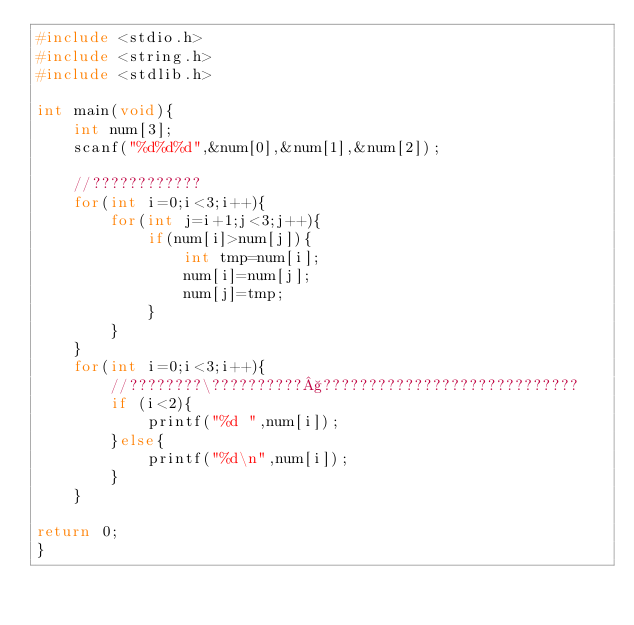<code> <loc_0><loc_0><loc_500><loc_500><_C_>#include <stdio.h>
#include <string.h>
#include <stdlib.h>

int main(void){
    int num[3];
    scanf("%d%d%d",&num[0],&num[1],&num[2]);
    
    //????????????
    for(int i=0;i<3;i++){
        for(int j=i+1;j<3;j++){
            if(num[i]>num[j]){
                int tmp=num[i];
                num[i]=num[j];
                num[j]=tmp;
            }   
        }
    }
    for(int i=0;i<3;i++){
        //????????\??????????§????????????????????????????
        if (i<2){
            printf("%d ",num[i]);
        }else{
            printf("%d\n",num[i]);
        }
    }

return 0;
}</code> 